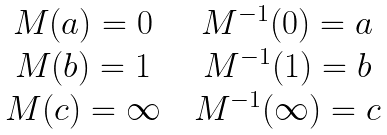<formula> <loc_0><loc_0><loc_500><loc_500>\begin{matrix} M ( a ) = 0 & & M ^ { - 1 } ( 0 ) = a \\ M ( b ) = 1 & & M ^ { - 1 } ( 1 ) = b \\ M ( c ) = \infty & & M ^ { - 1 } ( \infty ) = c \end{matrix}</formula> 